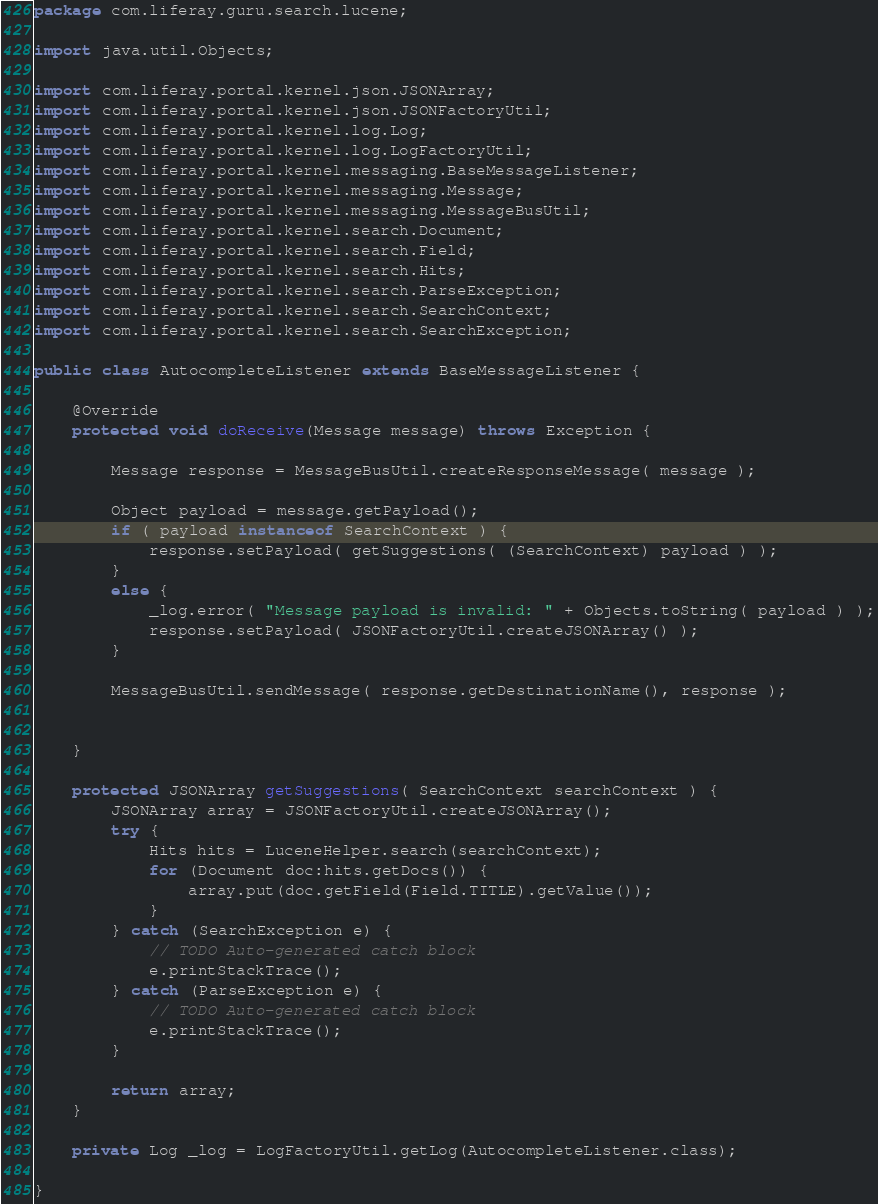Convert code to text. <code><loc_0><loc_0><loc_500><loc_500><_Java_>package com.liferay.guru.search.lucene;

import java.util.Objects;

import com.liferay.portal.kernel.json.JSONArray;
import com.liferay.portal.kernel.json.JSONFactoryUtil;
import com.liferay.portal.kernel.log.Log;
import com.liferay.portal.kernel.log.LogFactoryUtil;
import com.liferay.portal.kernel.messaging.BaseMessageListener;
import com.liferay.portal.kernel.messaging.Message;
import com.liferay.portal.kernel.messaging.MessageBusUtil;
import com.liferay.portal.kernel.search.Document;
import com.liferay.portal.kernel.search.Field;
import com.liferay.portal.kernel.search.Hits;
import com.liferay.portal.kernel.search.ParseException;
import com.liferay.portal.kernel.search.SearchContext;
import com.liferay.portal.kernel.search.SearchException;

public class AutocompleteListener extends BaseMessageListener {

	@Override
	protected void doReceive(Message message) throws Exception {

		Message response = MessageBusUtil.createResponseMessage( message );
		
		Object payload = message.getPayload();
        if ( payload instanceof SearchContext ) {
            response.setPayload( getSuggestions( (SearchContext) payload ) );
        }
        else {
            _log.error( "Message payload is invalid: " + Objects.toString( payload ) );
            response.setPayload( JSONFactoryUtil.createJSONArray() );
        }
		
		MessageBusUtil.sendMessage( response.getDestinationName(), response );
		
		
	}
	
	protected JSONArray getSuggestions( SearchContext searchContext ) {
		JSONArray array = JSONFactoryUtil.createJSONArray();
		try {
			Hits hits = LuceneHelper.search(searchContext);
			for (Document doc:hits.getDocs()) {
				array.put(doc.getField(Field.TITLE).getValue());
			}
		} catch (SearchException e) {
			// TODO Auto-generated catch block
			e.printStackTrace();
		} catch (ParseException e) {
			// TODO Auto-generated catch block
			e.printStackTrace();
		}
		
		return array;
	}
	
	private Log _log = LogFactoryUtil.getLog(AutocompleteListener.class);

}
</code> 